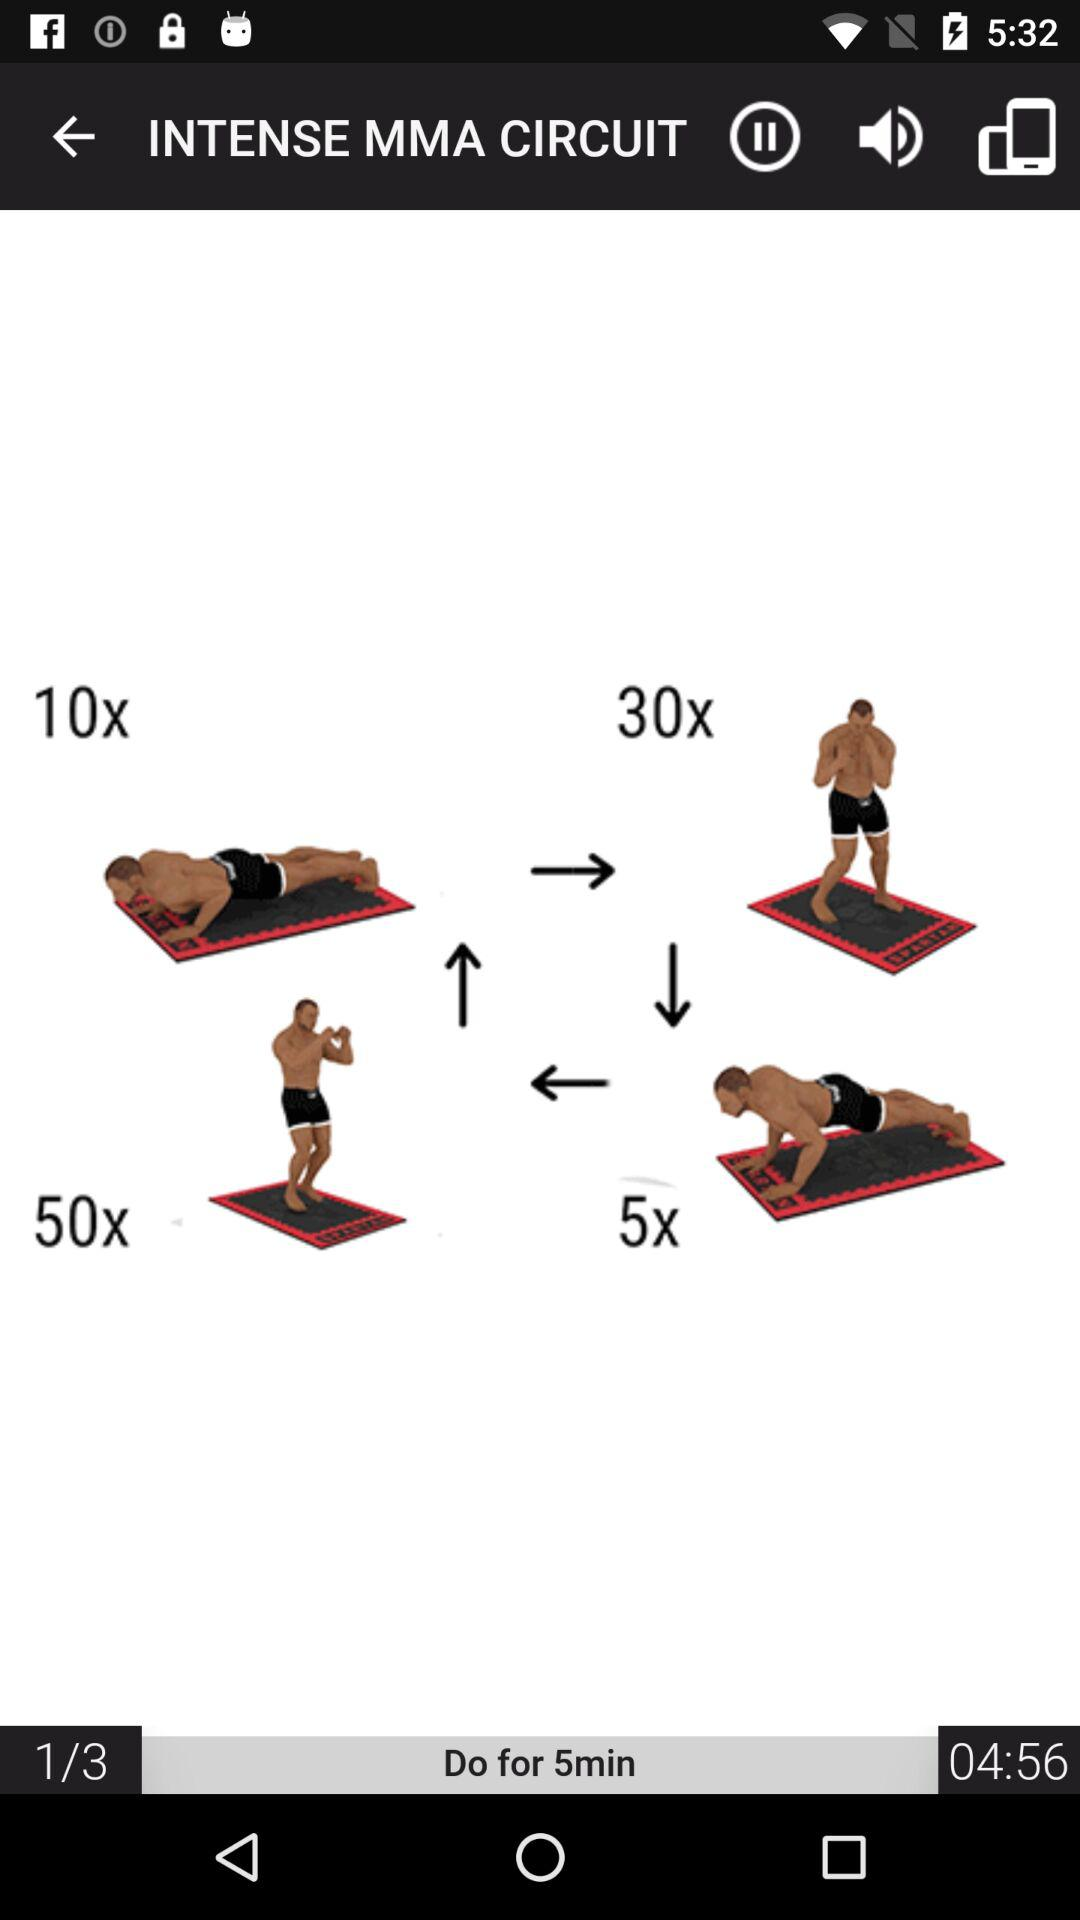How long do you need to work out? You need to work out for 5 minutes. 